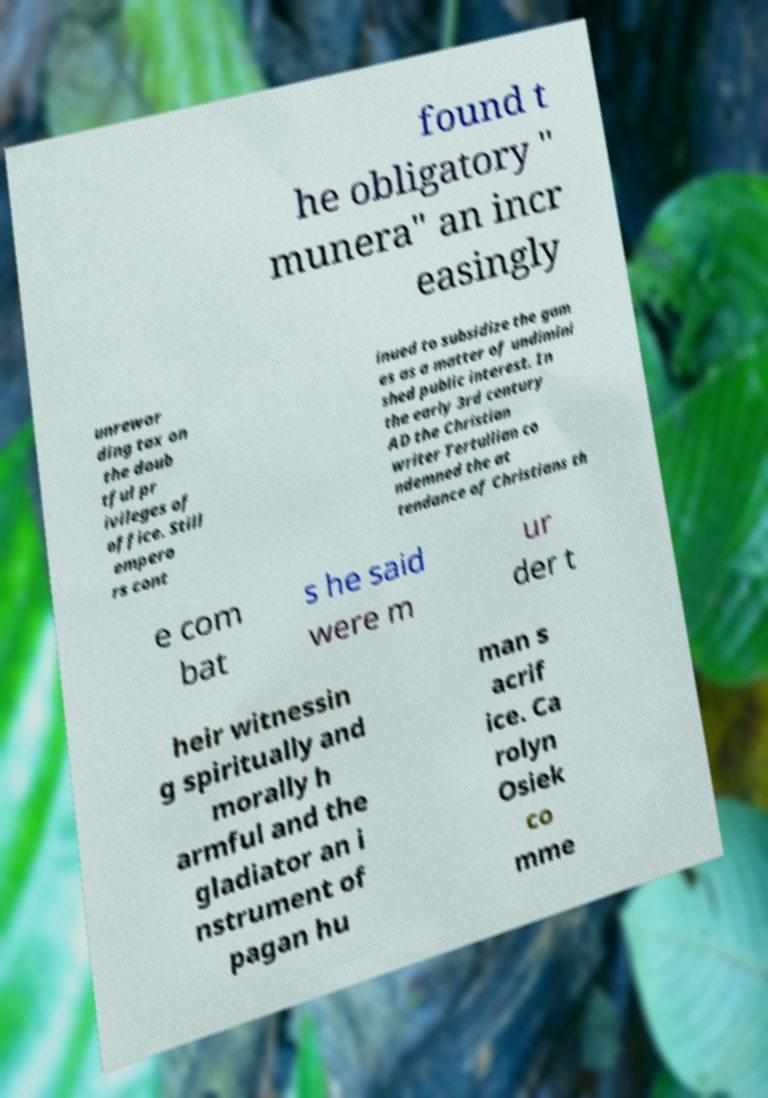There's text embedded in this image that I need extracted. Can you transcribe it verbatim? found t he obligatory " munera" an incr easingly unrewar ding tax on the doub tful pr ivileges of office. Still empero rs cont inued to subsidize the gam es as a matter of undimini shed public interest. In the early 3rd century AD the Christian writer Tertullian co ndemned the at tendance of Christians th e com bat s he said were m ur der t heir witnessin g spiritually and morally h armful and the gladiator an i nstrument of pagan hu man s acrif ice. Ca rolyn Osiek co mme 